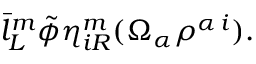<formula> <loc_0><loc_0><loc_500><loc_500>\bar { l } _ { L } ^ { m } \tilde { \phi } \eta _ { i R } ^ { m } ( \Omega _ { \alpha } \rho ^ { \alpha \, i } ) .</formula> 